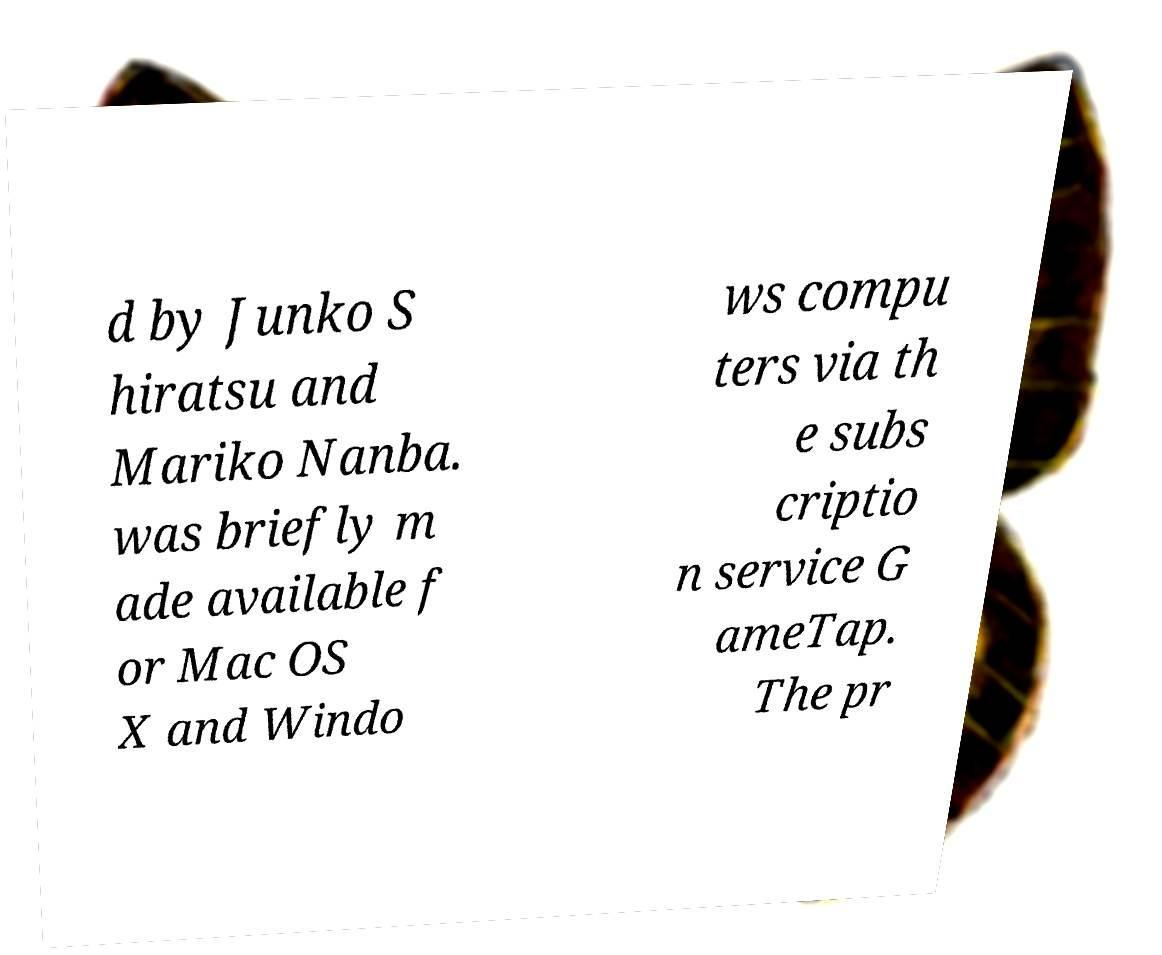I need the written content from this picture converted into text. Can you do that? d by Junko S hiratsu and Mariko Nanba. was briefly m ade available f or Mac OS X and Windo ws compu ters via th e subs criptio n service G ameTap. The pr 